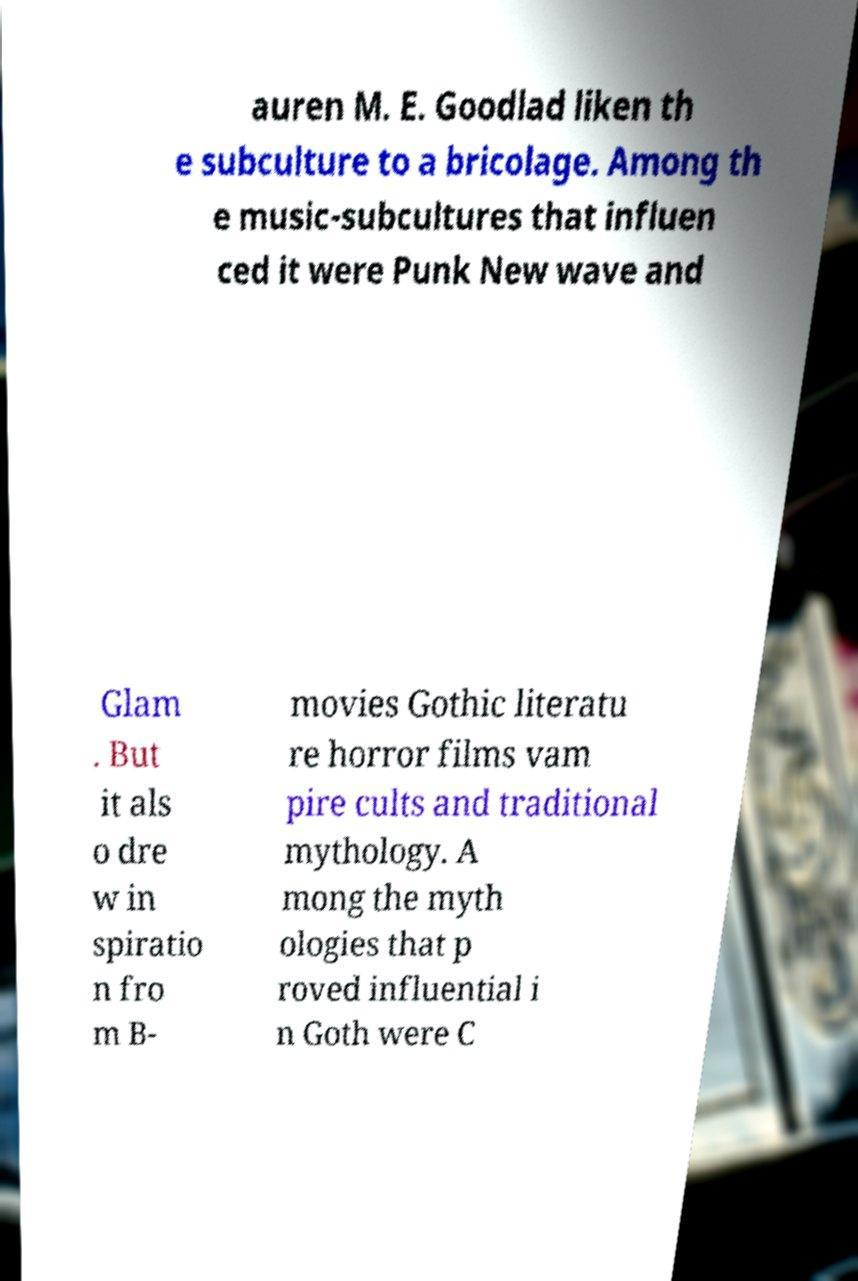I need the written content from this picture converted into text. Can you do that? auren M. E. Goodlad liken th e subculture to a bricolage. Among th e music-subcultures that influen ced it were Punk New wave and Glam . But it als o dre w in spiratio n fro m B- movies Gothic literatu re horror films vam pire cults and traditional mythology. A mong the myth ologies that p roved influential i n Goth were C 